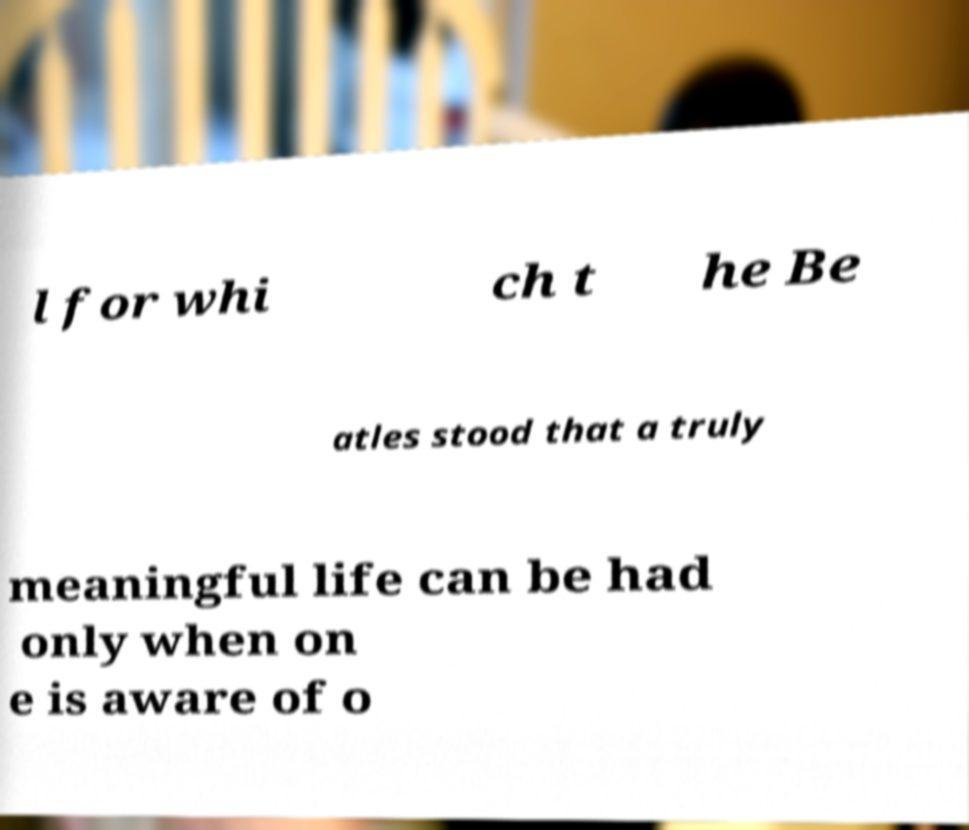Please identify and transcribe the text found in this image. l for whi ch t he Be atles stood that a truly meaningful life can be had only when on e is aware of o 